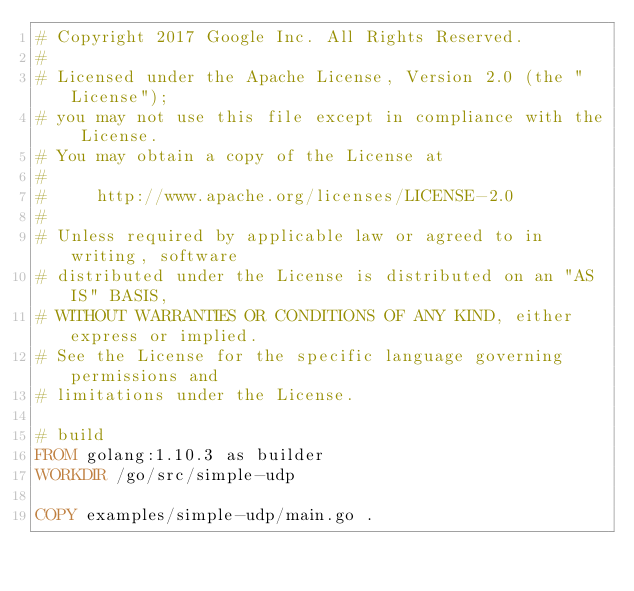<code> <loc_0><loc_0><loc_500><loc_500><_Dockerfile_># Copyright 2017 Google Inc. All Rights Reserved.
#
# Licensed under the Apache License, Version 2.0 (the "License");
# you may not use this file except in compliance with the License.
# You may obtain a copy of the License at
#
#     http://www.apache.org/licenses/LICENSE-2.0
#
# Unless required by applicable law or agreed to in writing, software
# distributed under the License is distributed on an "AS IS" BASIS,
# WITHOUT WARRANTIES OR CONDITIONS OF ANY KIND, either express or implied.
# See the License for the specific language governing permissions and
# limitations under the License.

# build
FROM golang:1.10.3 as builder
WORKDIR /go/src/simple-udp

COPY examples/simple-udp/main.go .</code> 